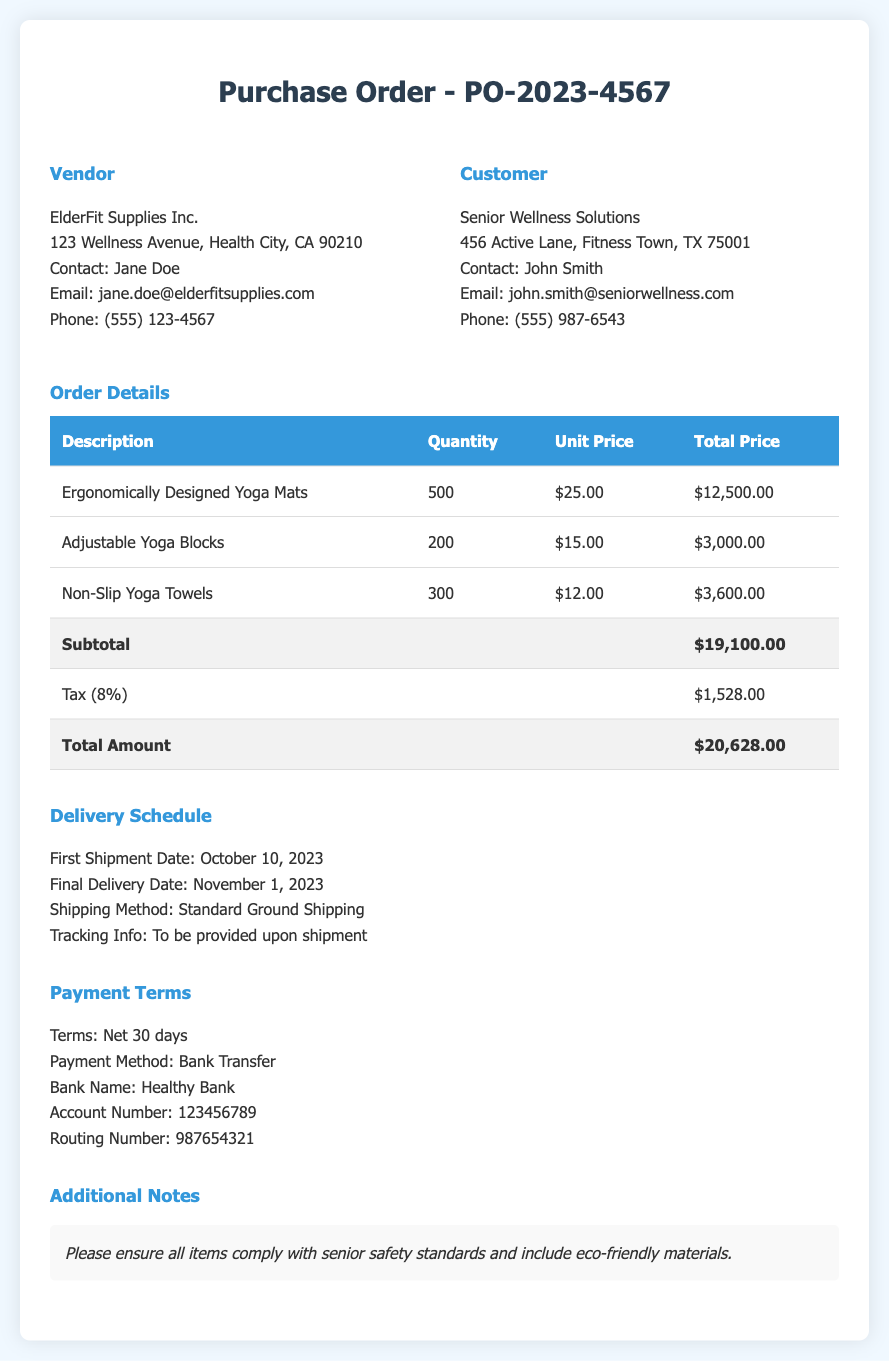What is the order number? The order number is indicated at the top of the document as PO-2023-4567.
Answer: PO-2023-4567 Who is the vendor? The vendor's name is mentioned in the document as ElderFit Supplies Inc.
Answer: ElderFit Supplies Inc What is the total amount? The total amount is shown at the bottom of the order details as $20,628.00.
Answer: $20,628.00 When is the first shipment date? The first shipment date is listed in the delivery schedule section as October 10, 2023.
Answer: October 10, 2023 What is the payment method? The payment method is specified in the payment terms section as Bank Transfer.
Answer: Bank Transfer How many ergonomically designed yoga mats are ordered? The quantity of yoga mats is detailed in the order details table as 500.
Answer: 500 What is the tax percentage applied? The tax percentage is mentioned in the document as 8%.
Answer: 8% What are the additional notes regarding the order? The additional notes mention ensuring compliance with senior safety standards and eco-friendly materials.
Answer: Ensure all items comply with senior safety standards and include eco-friendly materials What is the final delivery date? The final delivery date is indicated in the delivery schedule as November 1, 2023.
Answer: November 1, 2023 